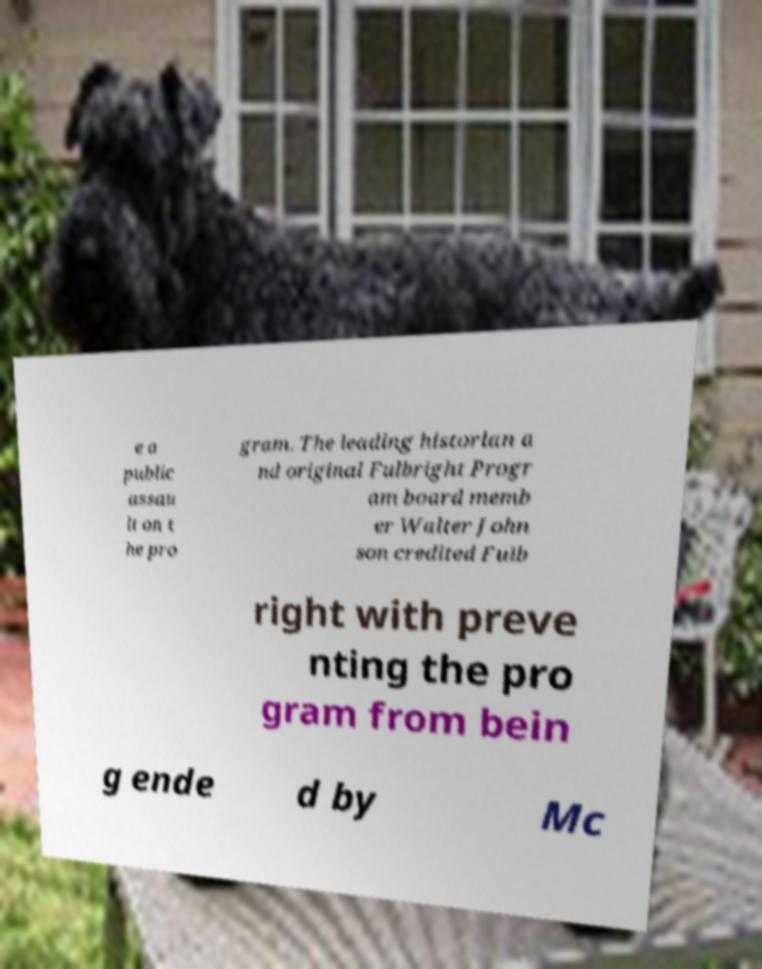Could you extract and type out the text from this image? e a public assau lt on t he pro gram. The leading historian a nd original Fulbright Progr am board memb er Walter John son credited Fulb right with preve nting the pro gram from bein g ende d by Mc 